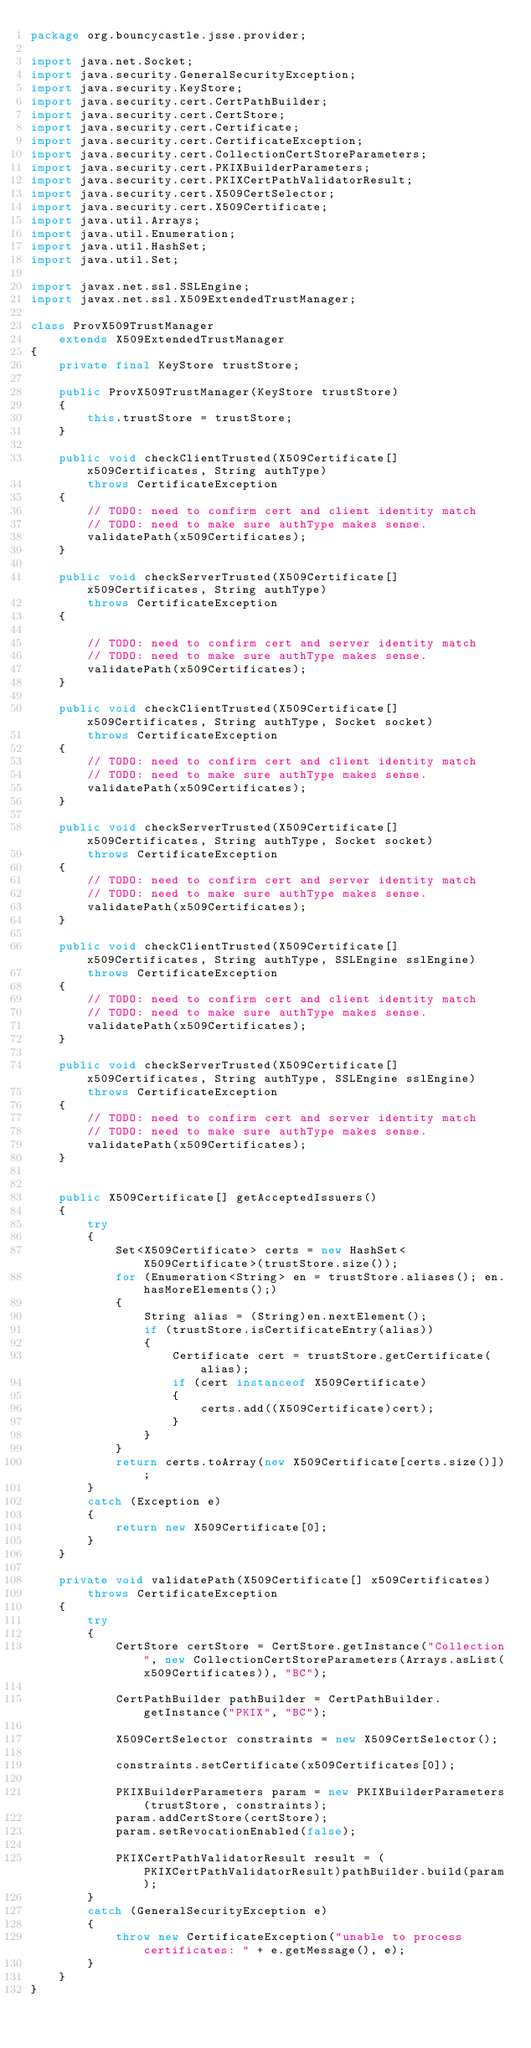<code> <loc_0><loc_0><loc_500><loc_500><_Java_>package org.bouncycastle.jsse.provider;

import java.net.Socket;
import java.security.GeneralSecurityException;
import java.security.KeyStore;
import java.security.cert.CertPathBuilder;
import java.security.cert.CertStore;
import java.security.cert.Certificate;
import java.security.cert.CertificateException;
import java.security.cert.CollectionCertStoreParameters;
import java.security.cert.PKIXBuilderParameters;
import java.security.cert.PKIXCertPathValidatorResult;
import java.security.cert.X509CertSelector;
import java.security.cert.X509Certificate;
import java.util.Arrays;
import java.util.Enumeration;
import java.util.HashSet;
import java.util.Set;

import javax.net.ssl.SSLEngine;
import javax.net.ssl.X509ExtendedTrustManager;

class ProvX509TrustManager
    extends X509ExtendedTrustManager
{
    private final KeyStore trustStore;

    public ProvX509TrustManager(KeyStore trustStore)
    {
        this.trustStore = trustStore;
    }

    public void checkClientTrusted(X509Certificate[] x509Certificates, String authType)
        throws CertificateException
    {
        // TODO: need to confirm cert and client identity match
        // TODO: need to make sure authType makes sense.
        validatePath(x509Certificates);
    }

    public void checkServerTrusted(X509Certificate[] x509Certificates, String authType)
        throws CertificateException
    {

        // TODO: need to confirm cert and server identity match
        // TODO: need to make sure authType makes sense.
        validatePath(x509Certificates);
    }

    public void checkClientTrusted(X509Certificate[] x509Certificates, String authType, Socket socket)
        throws CertificateException
    {
        // TODO: need to confirm cert and client identity match
        // TODO: need to make sure authType makes sense.
        validatePath(x509Certificates);
    }

    public void checkServerTrusted(X509Certificate[] x509Certificates, String authType, Socket socket)
        throws CertificateException
    {
        // TODO: need to confirm cert and server identity match
        // TODO: need to make sure authType makes sense.
        validatePath(x509Certificates);
    }

    public void checkClientTrusted(X509Certificate[] x509Certificates, String authType, SSLEngine sslEngine)
        throws CertificateException
    {
        // TODO: need to confirm cert and client identity match
        // TODO: need to make sure authType makes sense.
        validatePath(x509Certificates);
    }

    public void checkServerTrusted(X509Certificate[] x509Certificates, String authType, SSLEngine sslEngine)
        throws CertificateException
    {
        // TODO: need to confirm cert and server identity match
        // TODO: need to make sure authType makes sense.
        validatePath(x509Certificates);
    }


    public X509Certificate[] getAcceptedIssuers()
    {
        try
        {
            Set<X509Certificate> certs = new HashSet<X509Certificate>(trustStore.size());
            for (Enumeration<String> en = trustStore.aliases(); en.hasMoreElements();)
            {
                String alias = (String)en.nextElement();
                if (trustStore.isCertificateEntry(alias))
                {
                    Certificate cert = trustStore.getCertificate(alias);
                    if (cert instanceof X509Certificate)
                    {
                        certs.add((X509Certificate)cert);
                    }
                }
            }
            return certs.toArray(new X509Certificate[certs.size()]);
        }
        catch (Exception e)
        {
            return new X509Certificate[0];
        }
    }

    private void validatePath(X509Certificate[] x509Certificates)
        throws CertificateException
    {
        try
        {
            CertStore certStore = CertStore.getInstance("Collection", new CollectionCertStoreParameters(Arrays.asList(x509Certificates)), "BC");

            CertPathBuilder pathBuilder = CertPathBuilder.getInstance("PKIX", "BC");

            X509CertSelector constraints = new X509CertSelector();

            constraints.setCertificate(x509Certificates[0]);

            PKIXBuilderParameters param = new PKIXBuilderParameters(trustStore, constraints);
            param.addCertStore(certStore);
            param.setRevocationEnabled(false);

            PKIXCertPathValidatorResult result = (PKIXCertPathValidatorResult)pathBuilder.build(param);
        }
        catch (GeneralSecurityException e)
        {
            throw new CertificateException("unable to process certificates: " + e.getMessage(), e);
        }
    }
}
</code> 